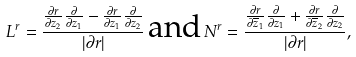Convert formula to latex. <formula><loc_0><loc_0><loc_500><loc_500>L ^ { r } = \frac { \frac { \partial r } { \partial z _ { 2 } } \frac { \partial } { \partial z _ { 1 } } - \frac { \partial r } { \partial z _ { 1 } } \frac { \partial } { \partial z _ { 2 } } } { | \partial r | } \, \text {and} \, N ^ { r } = \frac { \frac { \partial r } { \partial \overline { z } _ { 1 } } \frac { \partial } { \partial z _ { 1 } } + \frac { \partial r } { \partial \overline { z } _ { 2 } } \frac { \partial } { \partial z _ { 2 } } } { | \partial r | } ,</formula> 